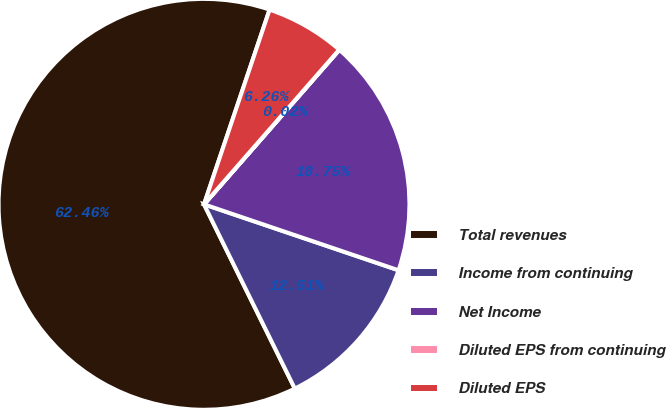<chart> <loc_0><loc_0><loc_500><loc_500><pie_chart><fcel>Total revenues<fcel>Income from continuing<fcel>Net Income<fcel>Diluted EPS from continuing<fcel>Diluted EPS<nl><fcel>62.46%<fcel>12.51%<fcel>18.75%<fcel>0.02%<fcel>6.26%<nl></chart> 